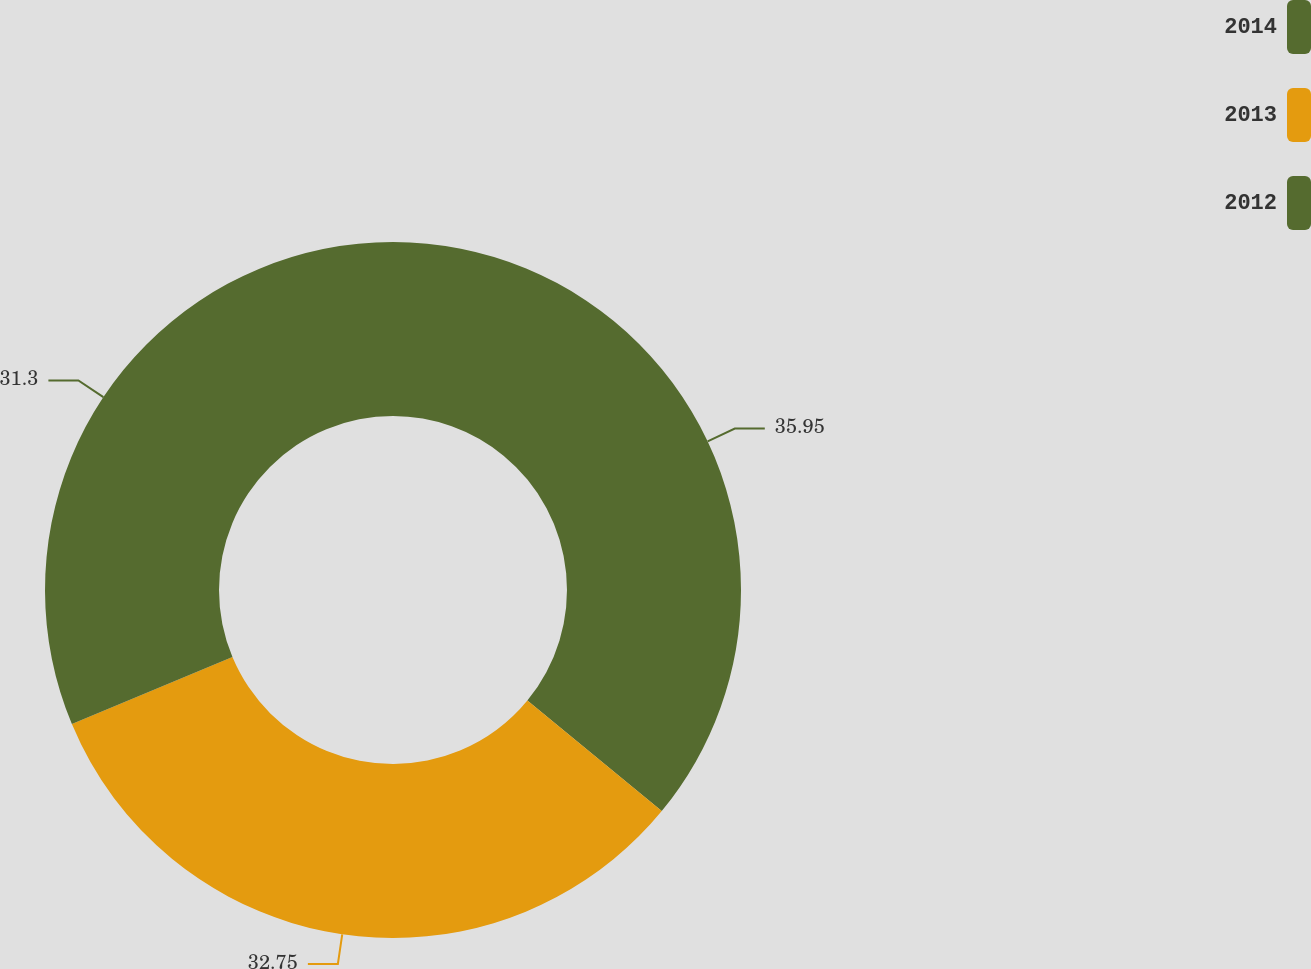Convert chart to OTSL. <chart><loc_0><loc_0><loc_500><loc_500><pie_chart><fcel>2014<fcel>2013<fcel>2012<nl><fcel>35.96%<fcel>32.75%<fcel>31.3%<nl></chart> 